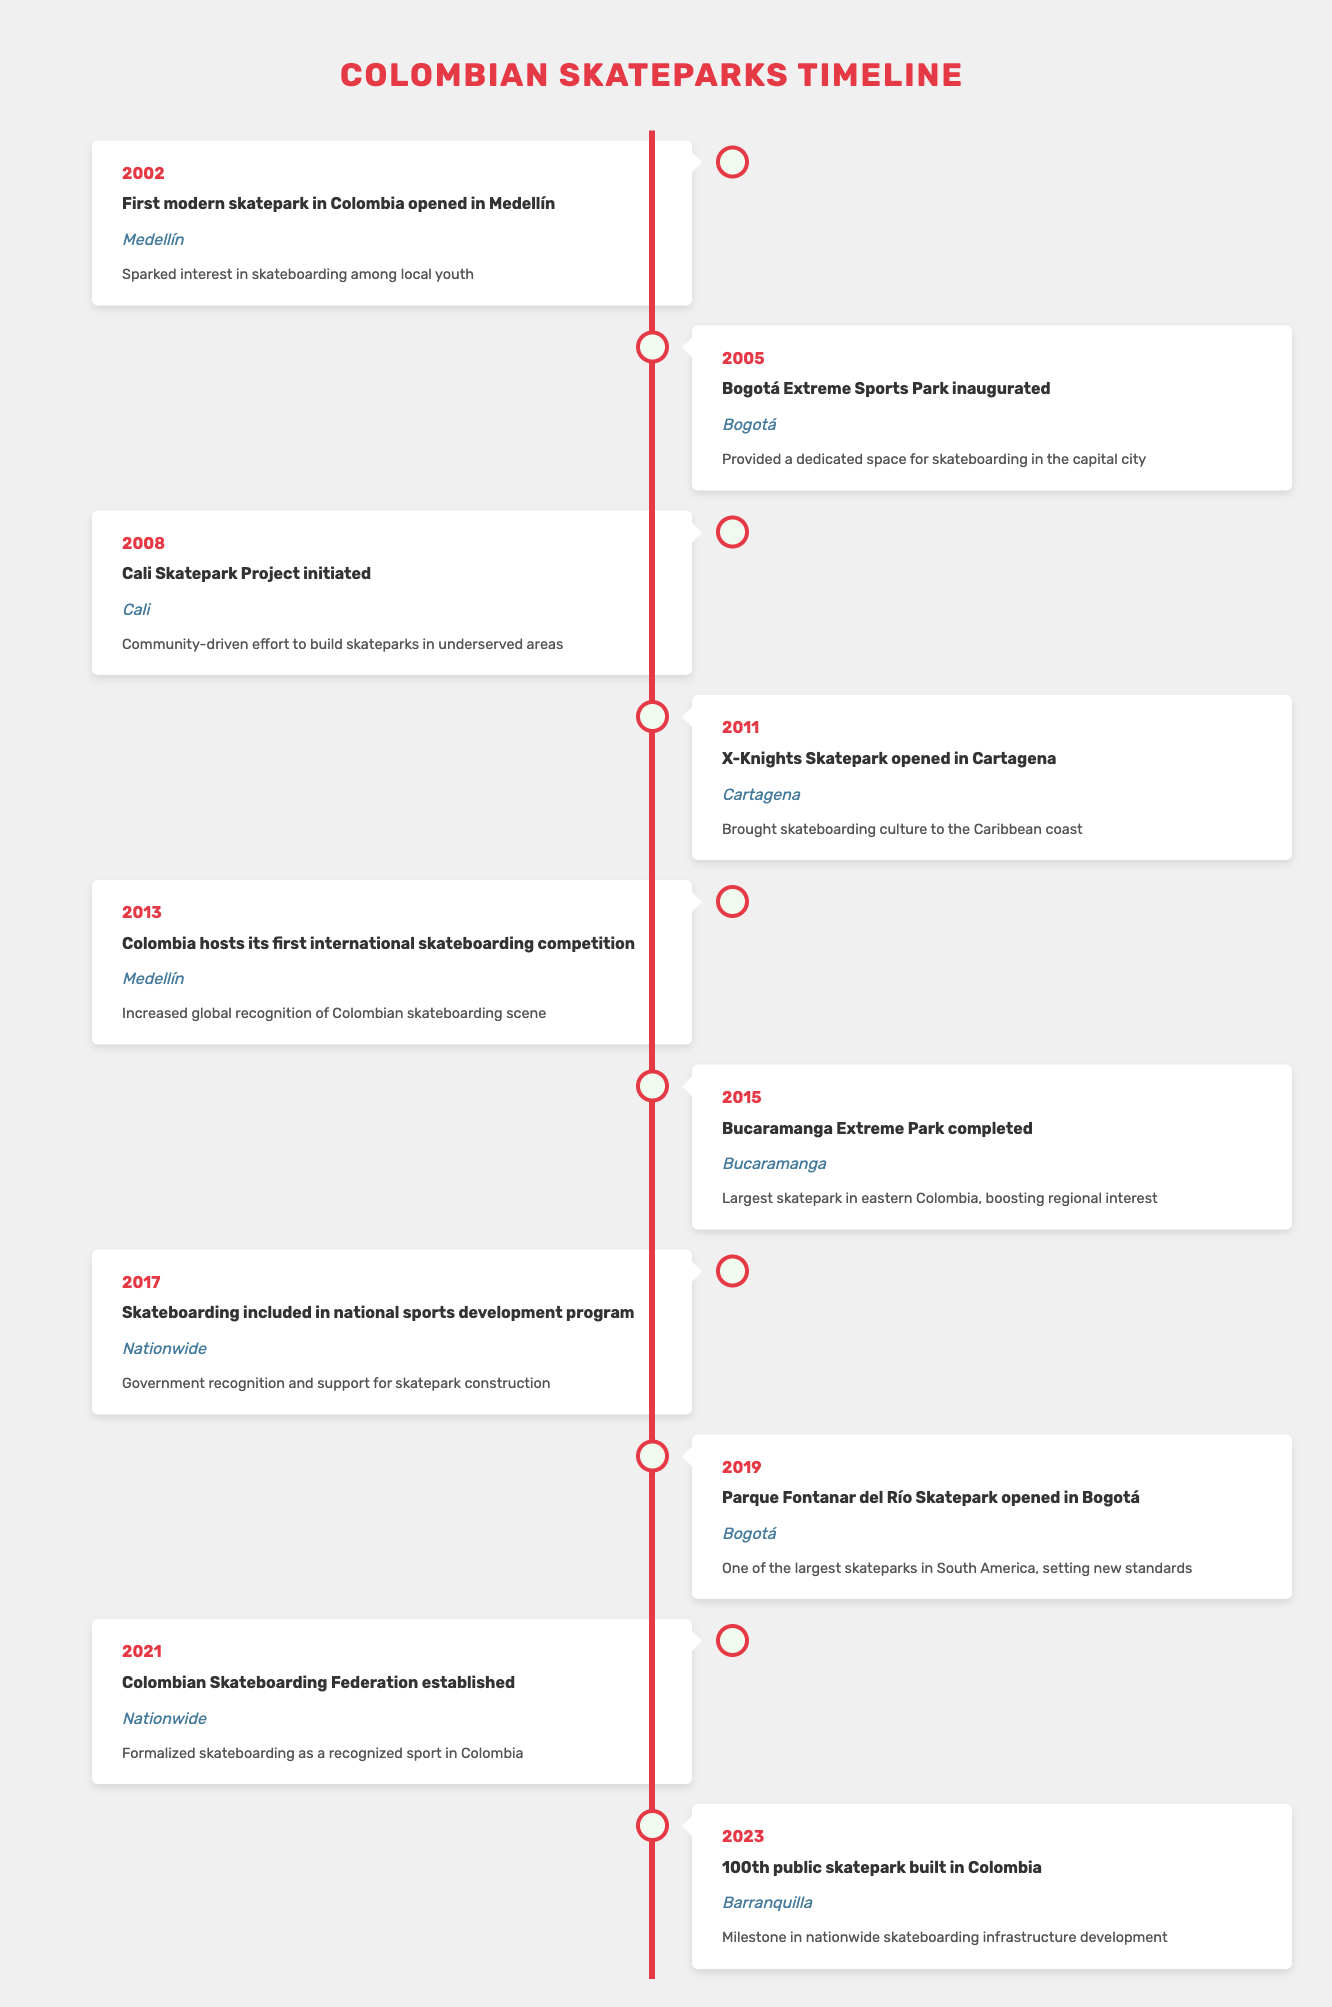What year did the first modern skatepark open in Colombia? The table lists the event of the "First modern skatepark in Colombia opened in Medellín" as happening in the year 2002.
Answer: 2002 How many skateparks were opened in Bogotá by 2019? According to the table, two skateparks were opened in Bogotá: the "Bogotá Extreme Sports Park" in 2005 and the "Parque Fontanar del Río Skatepark" in 2019.
Answer: 2 Is the Bucaramanga Extreme Park the largest skatepark in eastern Colombia? The table states that the "Bucaramanga Extreme Park" completed in 2015 is described as the "Largest skatepark in eastern Colombia," indicating that this statement is true.
Answer: Yes What are the years when skateboard events were initiated in Medellín? The table shows two events related to skateboarding in Medellín: the "First modern skatepark in Colombia opened" in 2002 and "Colombia hosts its first international skateboarding competition" in 2013. Both events are significant milestones for Medellín.
Answer: 2002, 2013 How many years passed between the opening of the first skatepark and the establishment of the Colombian Skateboarding Federation? The first skatepark opened in 2002 and the Colombian Skateboarding Federation was established in 2021. The difference between these years is 2021 - 2002 = 19 years.
Answer: 19 years Was there a government initiative for skateboarding recognized in 2017? The table indicates that in 2017, skateboarding was included in a national sports development program, which shows that there was indeed governmental recognition and support for the sport.
Answer: Yes What city witnessed the opening of the 100th public skatepark in Colombia? The table specifies that the 100th public skatepark was built in Barranquilla, as mentioned in the event for the year 2023.
Answer: Barranquilla How many skateparks were opened following the Cali Skatepark Project initiated in 2008 by 2023? The table includes the "Cali Skatepark Project initiated in 2008," but does not specify an exact number of skateparks opened as a result by 2023, besides the information that over that timeframe, a total of 100 public skateparks were built.
Answer: Not specified 